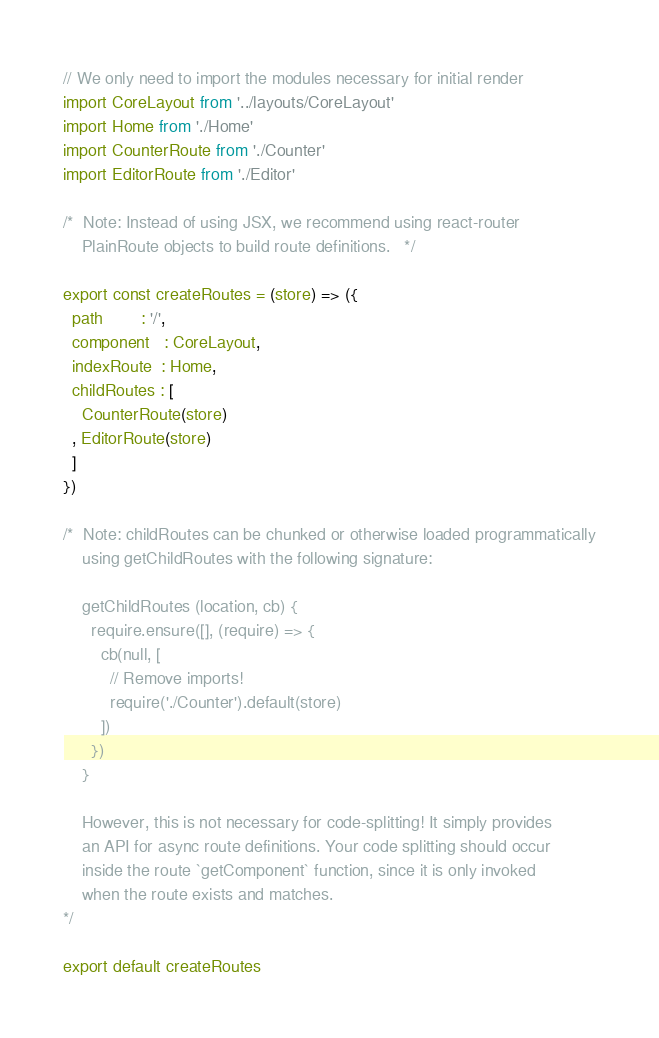<code> <loc_0><loc_0><loc_500><loc_500><_JavaScript_>// We only need to import the modules necessary for initial render
import CoreLayout from '../layouts/CoreLayout'
import Home from './Home'
import CounterRoute from './Counter'
import EditorRoute from './Editor'

/*  Note: Instead of using JSX, we recommend using react-router
    PlainRoute objects to build route definitions.   */

export const createRoutes = (store) => ({
  path        : '/',
  component   : CoreLayout,
  indexRoute  : Home,
  childRoutes : [
    CounterRoute(store)
  , EditorRoute(store)
  ]
})

/*  Note: childRoutes can be chunked or otherwise loaded programmatically
    using getChildRoutes with the following signature:

    getChildRoutes (location, cb) {
      require.ensure([], (require) => {
        cb(null, [
          // Remove imports!
          require('./Counter').default(store)
        ])
      })
    }

    However, this is not necessary for code-splitting! It simply provides
    an API for async route definitions. Your code splitting should occur
    inside the route `getComponent` function, since it is only invoked
    when the route exists and matches.
*/

export default createRoutes
</code> 